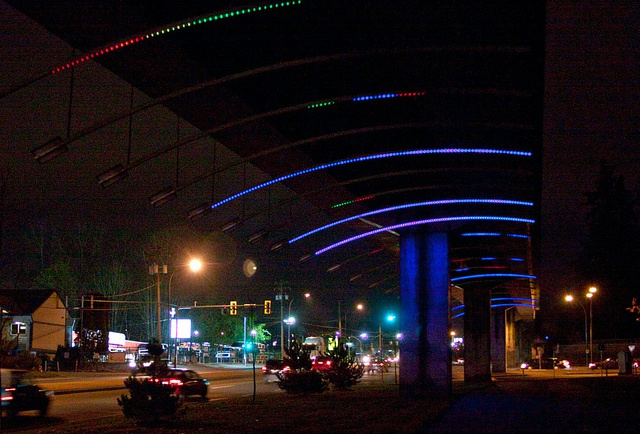Describe the objects in this image and their specific colors. I can see car in black, maroon, teal, and gray tones, car in black, maroon, white, and brown tones, car in black, maroon, and gray tones, car in black, maroon, brown, and white tones, and car in black, brown, maroon, and white tones in this image. 